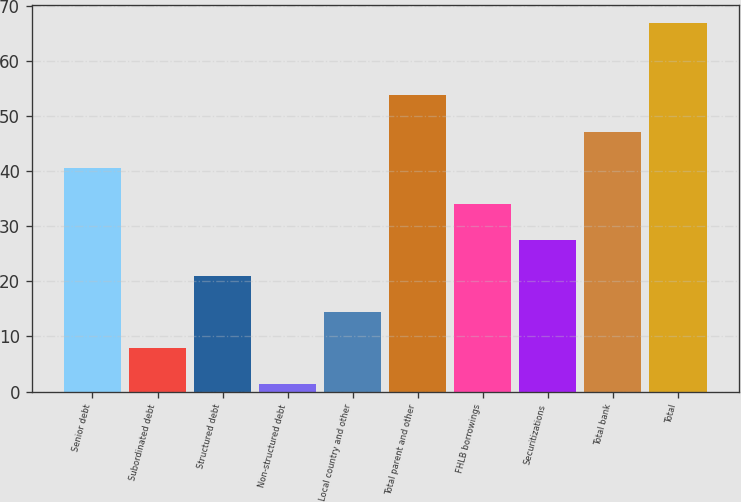<chart> <loc_0><loc_0><loc_500><loc_500><bar_chart><fcel>Senior debt<fcel>Subordinated debt<fcel>Structured debt<fcel>Non-structured debt<fcel>Local country and other<fcel>Total parent and other<fcel>FHLB borrowings<fcel>Securitizations<fcel>Total bank<fcel>Total<nl><fcel>40.64<fcel>7.94<fcel>21.02<fcel>1.4<fcel>14.48<fcel>53.72<fcel>34.1<fcel>27.56<fcel>47.18<fcel>66.8<nl></chart> 